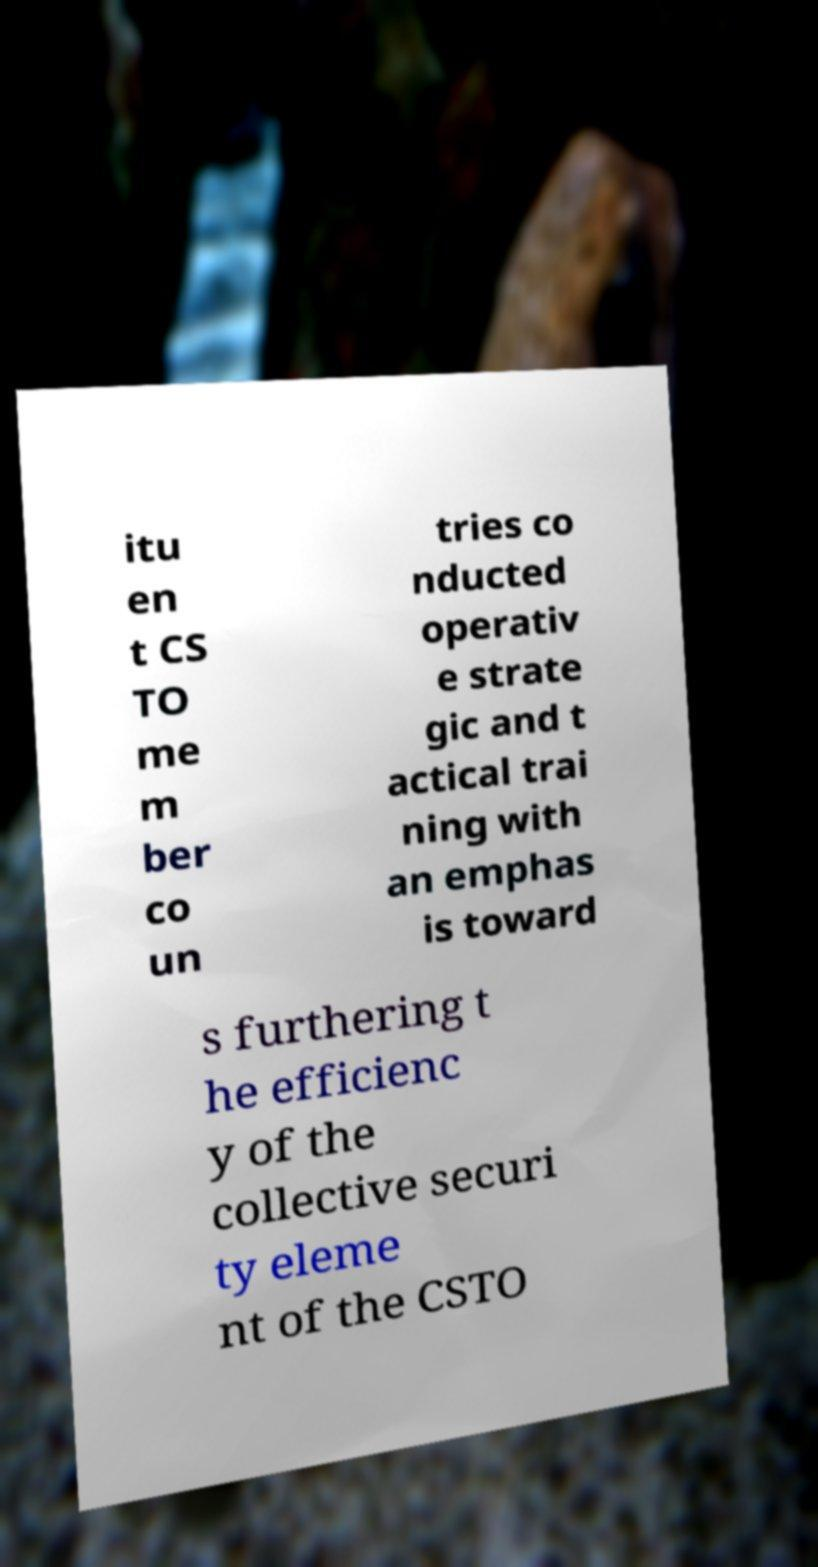I need the written content from this picture converted into text. Can you do that? itu en t CS TO me m ber co un tries co nducted operativ e strate gic and t actical trai ning with an emphas is toward s furthering t he efficienc y of the collective securi ty eleme nt of the CSTO 